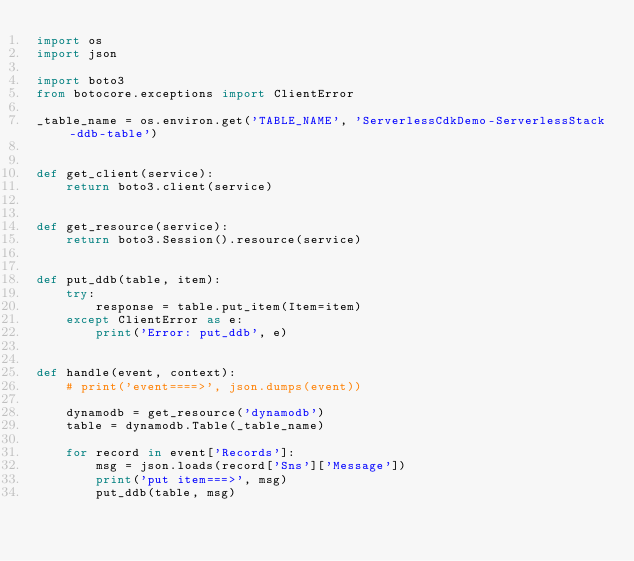Convert code to text. <code><loc_0><loc_0><loc_500><loc_500><_Python_>import os
import json

import boto3
from botocore.exceptions import ClientError

_table_name = os.environ.get('TABLE_NAME', 'ServerlessCdkDemo-ServerlessStack-ddb-table')


def get_client(service):
    return boto3.client(service)


def get_resource(service):
    return boto3.Session().resource(service)


def put_ddb(table, item):
    try:
        response = table.put_item(Item=item)
    except ClientError as e:
        print('Error: put_ddb', e)


def handle(event, context):
    # print('event====>', json.dumps(event))

    dynamodb = get_resource('dynamodb')
    table = dynamodb.Table(_table_name)

    for record in event['Records']:
        msg = json.loads(record['Sns']['Message'])
        print('put item===>', msg)
        put_ddb(table, msg)</code> 